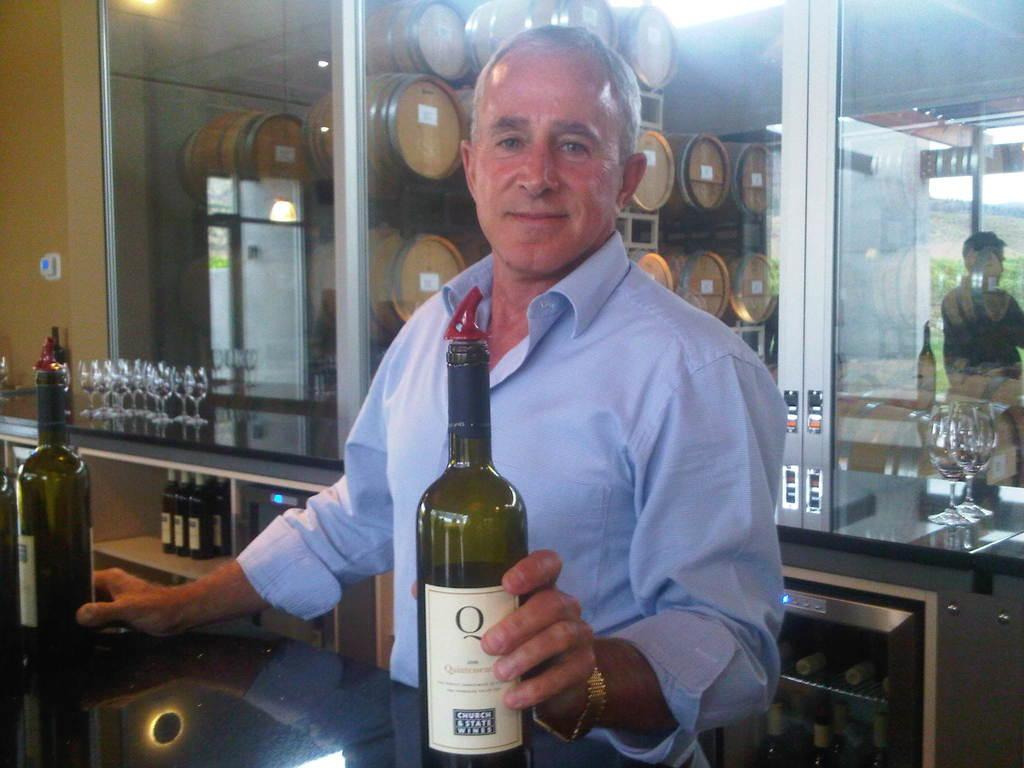<image>
Present a compact description of the photo's key features. a man holds a bottle of wine in a bar with a Q on it 